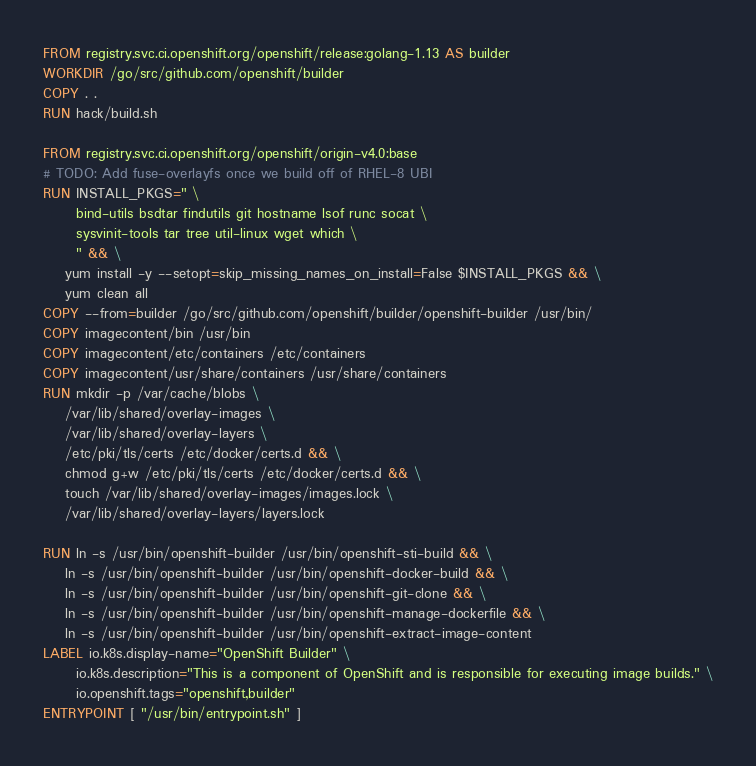Convert code to text. <code><loc_0><loc_0><loc_500><loc_500><_Dockerfile_>FROM registry.svc.ci.openshift.org/openshift/release:golang-1.13 AS builder
WORKDIR /go/src/github.com/openshift/builder
COPY . .
RUN hack/build.sh

FROM registry.svc.ci.openshift.org/openshift/origin-v4.0:base
# TODO: Add fuse-overlayfs once we build off of RHEL-8 UBI
RUN INSTALL_PKGS=" \
      bind-utils bsdtar findutils git hostname lsof runc socat \
      sysvinit-tools tar tree util-linux wget which \
      " && \
    yum install -y --setopt=skip_missing_names_on_install=False $INSTALL_PKGS && \
    yum clean all
COPY --from=builder /go/src/github.com/openshift/builder/openshift-builder /usr/bin/
COPY imagecontent/bin /usr/bin
COPY imagecontent/etc/containers /etc/containers
COPY imagecontent/usr/share/containers /usr/share/containers
RUN mkdir -p /var/cache/blobs \
    /var/lib/shared/overlay-images \
    /var/lib/shared/overlay-layers \
    /etc/pki/tls/certs /etc/docker/certs.d && \
    chmod g+w /etc/pki/tls/certs /etc/docker/certs.d && \
    touch /var/lib/shared/overlay-images/images.lock \
    /var/lib/shared/overlay-layers/layers.lock

RUN ln -s /usr/bin/openshift-builder /usr/bin/openshift-sti-build && \
    ln -s /usr/bin/openshift-builder /usr/bin/openshift-docker-build && \
    ln -s /usr/bin/openshift-builder /usr/bin/openshift-git-clone && \
    ln -s /usr/bin/openshift-builder /usr/bin/openshift-manage-dockerfile && \
    ln -s /usr/bin/openshift-builder /usr/bin/openshift-extract-image-content
LABEL io.k8s.display-name="OpenShift Builder" \
      io.k8s.description="This is a component of OpenShift and is responsible for executing image builds." \
      io.openshift.tags="openshift,builder"
ENTRYPOINT [ "/usr/bin/entrypoint.sh" ]
</code> 